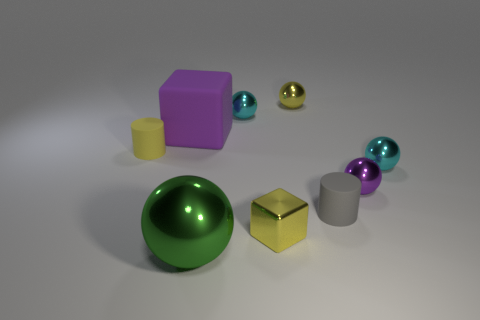Subtract all small yellow metallic balls. How many balls are left? 4 Subtract all green spheres. How many spheres are left? 4 Add 1 small yellow shiny balls. How many objects exist? 10 Subtract all brown balls. Subtract all green cylinders. How many balls are left? 5 Subtract all spheres. How many objects are left? 4 Subtract 0 purple cylinders. How many objects are left? 9 Subtract all rubber cylinders. Subtract all large cylinders. How many objects are left? 7 Add 3 gray matte objects. How many gray matte objects are left? 4 Add 8 cyan shiny cylinders. How many cyan shiny cylinders exist? 8 